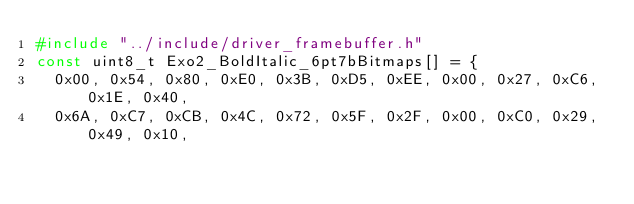Convert code to text. <code><loc_0><loc_0><loc_500><loc_500><_C_>#include "../include/driver_framebuffer.h"
const uint8_t Exo2_BoldItalic_6pt7bBitmaps[] = {
  0x00, 0x54, 0x80, 0xE0, 0x3B, 0xD5, 0xEE, 0x00, 0x27, 0xC6, 0x1E, 0x40,
  0x6A, 0xC7, 0xCB, 0x4C, 0x72, 0x5F, 0x2F, 0x00, 0xC0, 0x29, 0x49, 0x10,</code> 